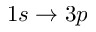Convert formula to latex. <formula><loc_0><loc_0><loc_500><loc_500>1 s \rightarrow 3 p</formula> 